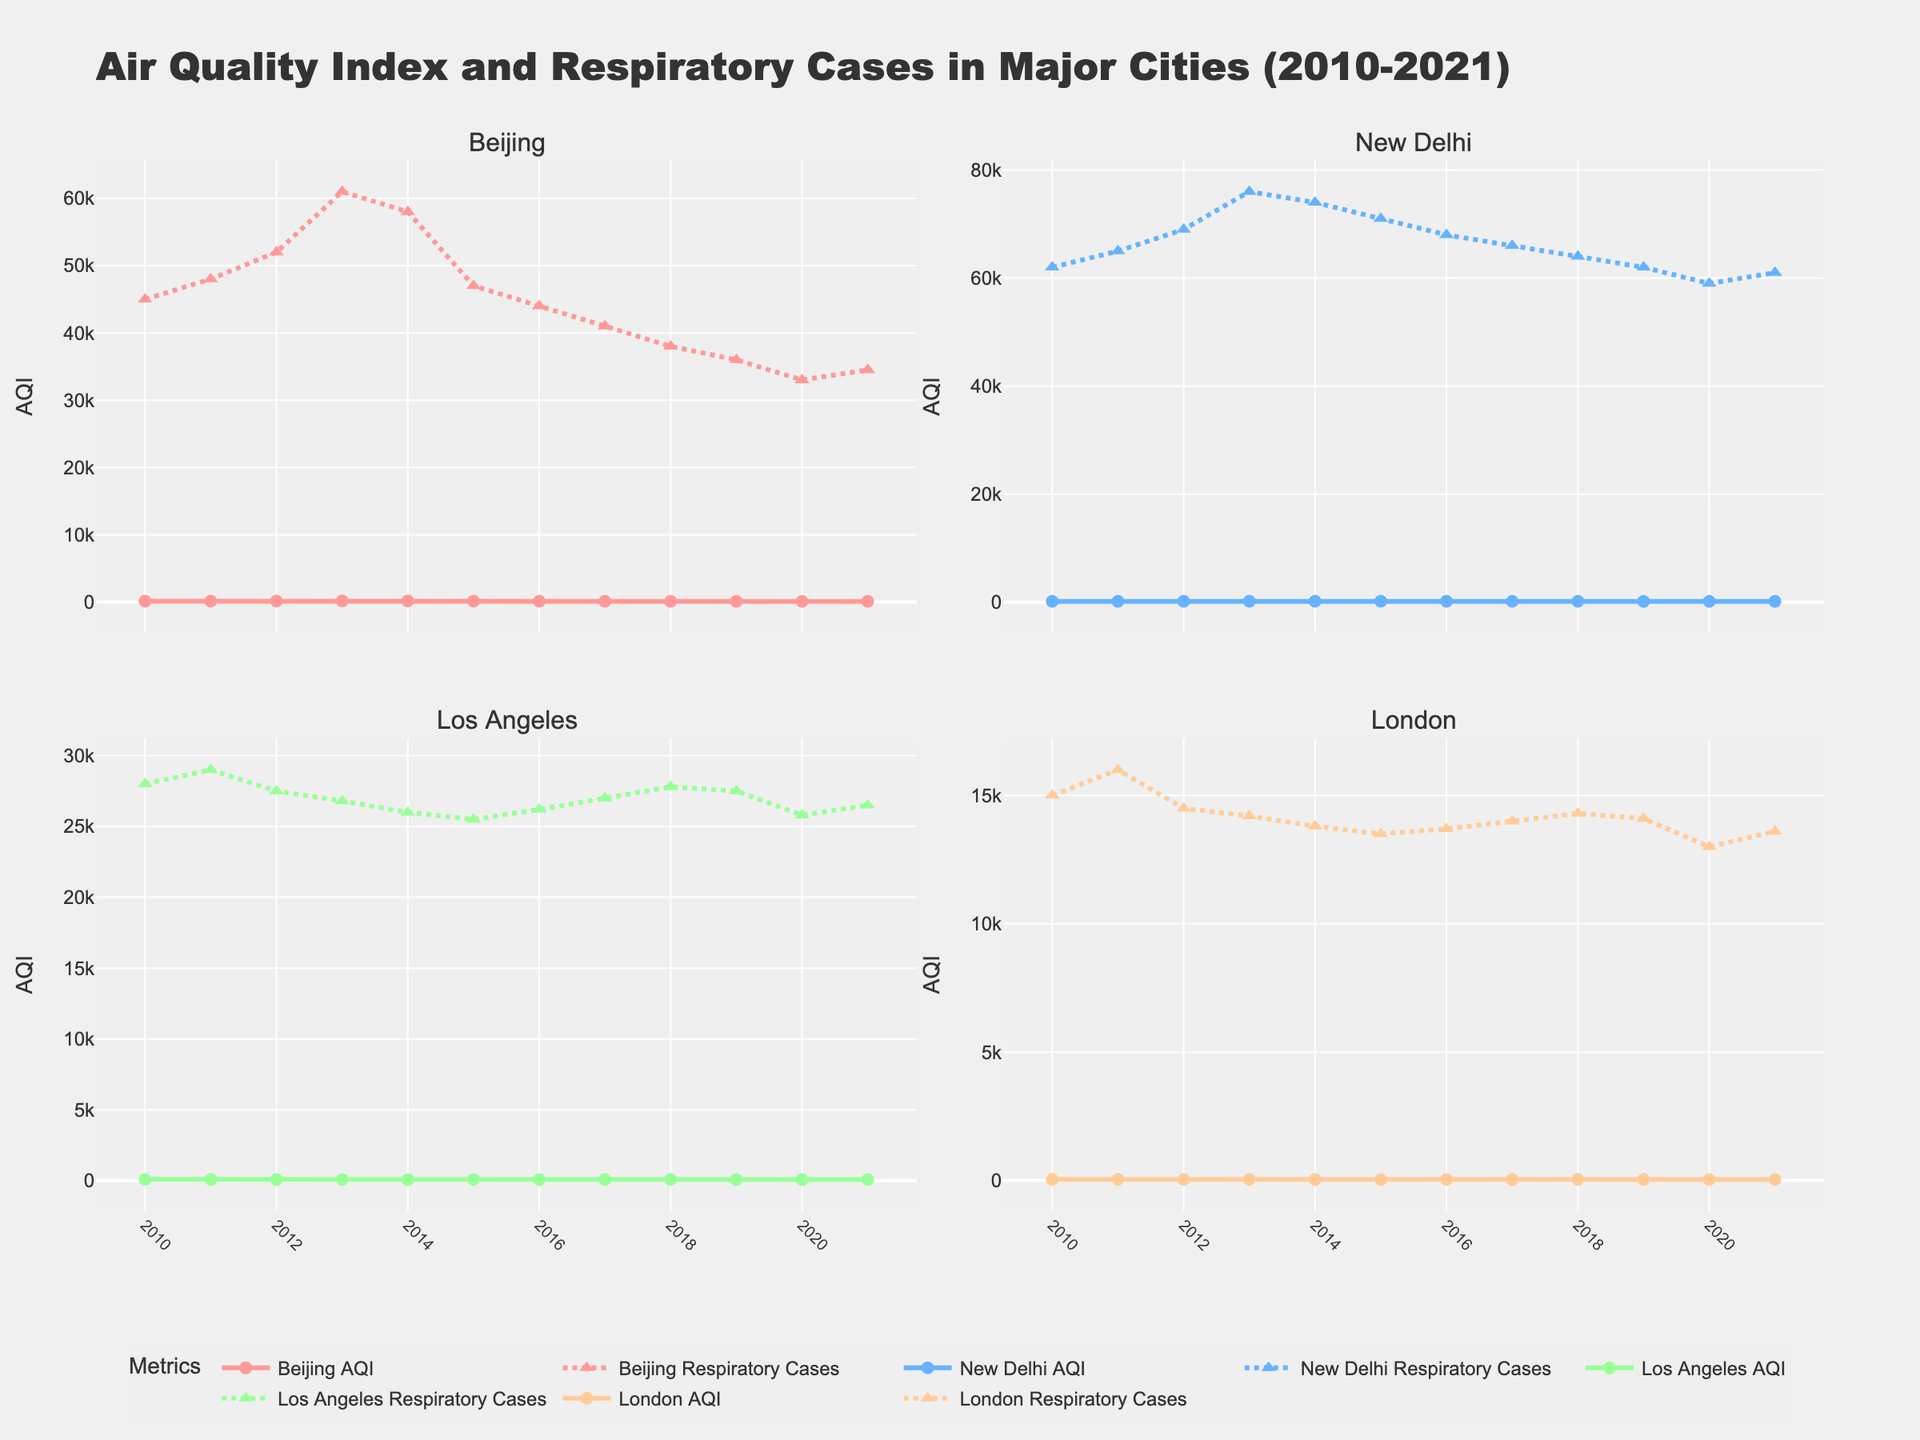What general trend can be observed in Beijing's AQI from 2010 to 2021? The graph for Beijing AQI shows a general decreasing trend, particularly after a peak around 2013, indicating an improvement in air quality over time.
Answer: Decreasing How do the trends in AQI for Los Angeles and London compare between 2010 and 2021? The AQI for Los Angeles appears to be relatively stable with minor fluctuations, while London's AQI shows a steady decrease over the same period.
Answer: Los Angeles: Stable, London: Decreasing Which city had the highest AQI in the year 2013? By looking at the AQI lines for all four cities in 2013, New Delhi's AQI was the highest among them.
Answer: New Delhi Which city's AQI improved the most by 2021 compared to 2010? Comparing the AQI for each city from 2010 to 2021, Beijing's AQI shows the largest decrease, indicating the most improvement in air quality.
Answer: Beijing Is there a correlation between AQI and respiratory cases for any of the cities? Observing the patterns of AQI and respiratory cases for each city, both tend to move similarly; an increase in AQI is associated with an increase in respiratory cases, and vice versa. This suggests a correlation between AQI and respiratory cases.
Answer: Yes For New Delhi, what was the average AQI over the years from 2010 to 2021? To find the average AQI for New Delhi, sum the AQI values from 2010 to 2021 and then divide by the number of years: (168 + 172 + 180 + 195 + 190 + 184 + 177 + 172 + 168 + 162 + 156 + 160) / 12 = 1804 / 12 = 150.33
Answer: 150.33 Which city had the lowest number of respiratory cases in 2021? By checking the respiratory cases data for all cities in the year 2021, London had the lowest number of respiratory cases.
Answer: London How did respiratory cases in Beijing change from 2010 to 2021? The number of respiratory cases in Beijing shows a decreasing trend from 45000 cases in 2010 to 34500 cases in 2021, with a peak around 2013.
Answer: Decreasing Which two cities show similar patterns in AQI trends over the years? By comparing the AQI lines across years, Los Angeles and London have relatively stable or slightly decreasing AQI trends, showing similar patterns.
Answer: Los Angeles and London What is the difference in AQI between New Delhi and London in 2018? The AQI for New Delhi in 2018 is 168, and for London, it is 42. The difference is 168 - 42 = 126.
Answer: 126 